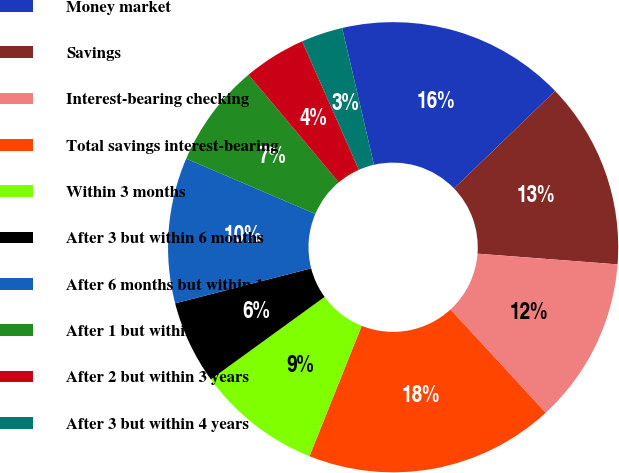<chart> <loc_0><loc_0><loc_500><loc_500><pie_chart><fcel>Money market<fcel>Savings<fcel>Interest-bearing checking<fcel>Total savings interest-bearing<fcel>Within 3 months<fcel>After 3 but within 6 months<fcel>After 6 months but within 1<fcel>After 1 but within 2 years<fcel>After 2 but within 3 years<fcel>After 3 but within 4 years<nl><fcel>16.42%<fcel>13.43%<fcel>11.94%<fcel>17.91%<fcel>8.96%<fcel>5.97%<fcel>10.45%<fcel>7.46%<fcel>4.48%<fcel>2.99%<nl></chart> 